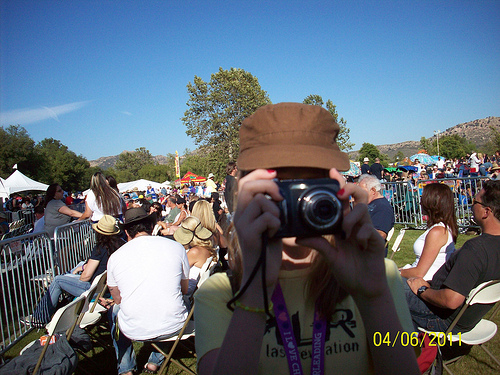<image>
Is there a camera behind the shirt? No. The camera is not behind the shirt. From this viewpoint, the camera appears to be positioned elsewhere in the scene. 